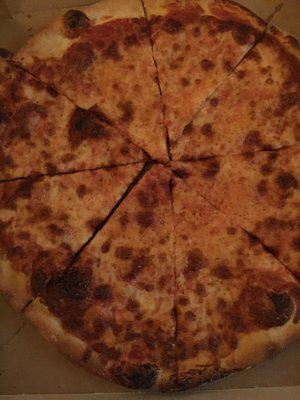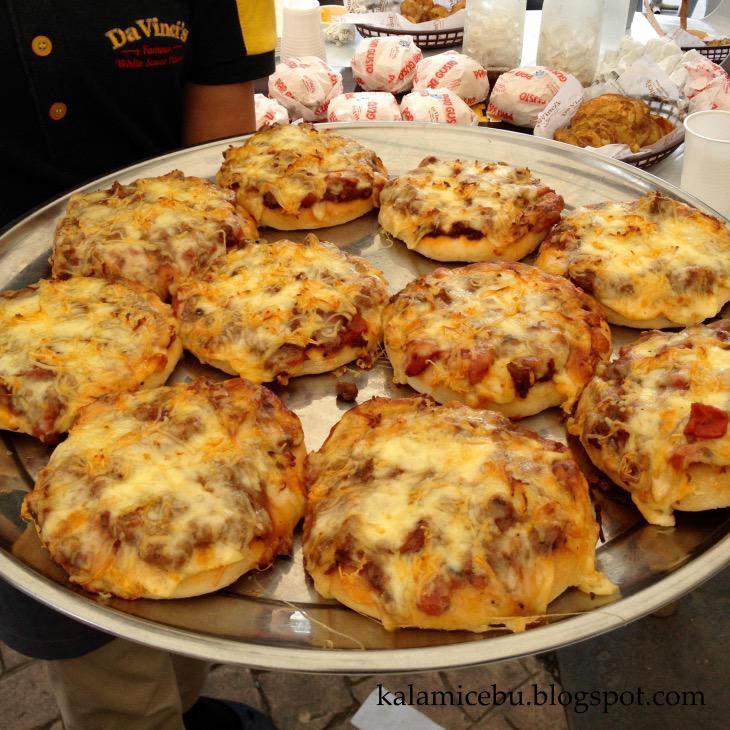The first image is the image on the left, the second image is the image on the right. Assess this claim about the two images: "The left and right image contains the same number of  uneaten pizzas.". Correct or not? Answer yes or no. No. The first image is the image on the left, the second image is the image on the right. For the images displayed, is the sentence "Each image contains one round pizza that is not in a box and does not have any slices missing." factually correct? Answer yes or no. No. 